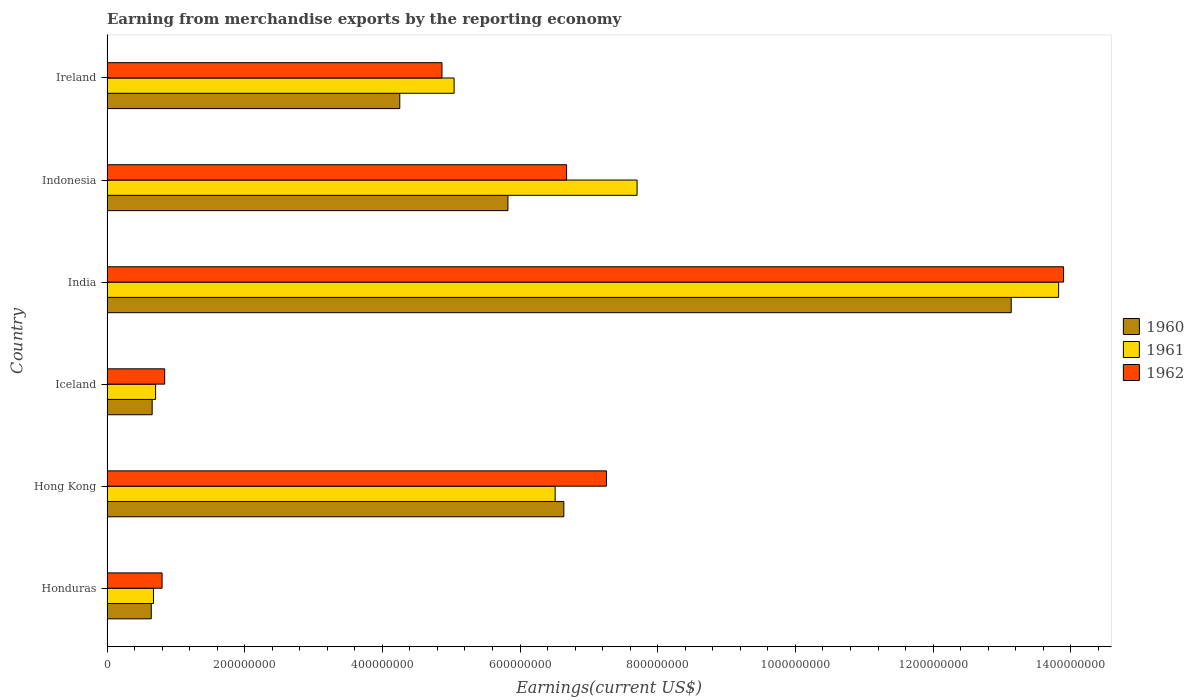How many groups of bars are there?
Your answer should be compact. 6. Are the number of bars on each tick of the Y-axis equal?
Your answer should be compact. Yes. How many bars are there on the 6th tick from the top?
Provide a short and direct response. 3. How many bars are there on the 3rd tick from the bottom?
Offer a terse response. 3. What is the amount earned from merchandise exports in 1962 in Honduras?
Offer a terse response. 8.00e+07. Across all countries, what is the maximum amount earned from merchandise exports in 1962?
Offer a terse response. 1.39e+09. Across all countries, what is the minimum amount earned from merchandise exports in 1962?
Give a very brief answer. 8.00e+07. In which country was the amount earned from merchandise exports in 1961 maximum?
Provide a short and direct response. India. In which country was the amount earned from merchandise exports in 1960 minimum?
Make the answer very short. Honduras. What is the total amount earned from merchandise exports in 1960 in the graph?
Give a very brief answer. 3.11e+09. What is the difference between the amount earned from merchandise exports in 1961 in Hong Kong and that in Indonesia?
Offer a very short reply. -1.19e+08. What is the difference between the amount earned from merchandise exports in 1960 in Honduras and the amount earned from merchandise exports in 1962 in Ireland?
Your response must be concise. -4.22e+08. What is the average amount earned from merchandise exports in 1961 per country?
Provide a succinct answer. 5.74e+08. What is the difference between the amount earned from merchandise exports in 1961 and amount earned from merchandise exports in 1960 in Honduras?
Your answer should be very brief. 3.20e+06. What is the ratio of the amount earned from merchandise exports in 1961 in Honduras to that in India?
Ensure brevity in your answer.  0.05. Is the amount earned from merchandise exports in 1962 in Iceland less than that in India?
Your answer should be compact. Yes. What is the difference between the highest and the second highest amount earned from merchandise exports in 1961?
Your answer should be very brief. 6.12e+08. What is the difference between the highest and the lowest amount earned from merchandise exports in 1961?
Offer a very short reply. 1.31e+09. What does the 1st bar from the top in Indonesia represents?
Offer a very short reply. 1962. How many bars are there?
Keep it short and to the point. 18. What is the difference between two consecutive major ticks on the X-axis?
Ensure brevity in your answer.  2.00e+08. Does the graph contain any zero values?
Ensure brevity in your answer.  No. Where does the legend appear in the graph?
Provide a short and direct response. Center right. How many legend labels are there?
Provide a short and direct response. 3. What is the title of the graph?
Provide a short and direct response. Earning from merchandise exports by the reporting economy. Does "1981" appear as one of the legend labels in the graph?
Offer a very short reply. No. What is the label or title of the X-axis?
Keep it short and to the point. Earnings(current US$). What is the label or title of the Y-axis?
Offer a very short reply. Country. What is the Earnings(current US$) of 1960 in Honduras?
Your answer should be very brief. 6.43e+07. What is the Earnings(current US$) in 1961 in Honduras?
Ensure brevity in your answer.  6.75e+07. What is the Earnings(current US$) in 1962 in Honduras?
Give a very brief answer. 8.00e+07. What is the Earnings(current US$) of 1960 in Hong Kong?
Offer a terse response. 6.64e+08. What is the Earnings(current US$) of 1961 in Hong Kong?
Give a very brief answer. 6.51e+08. What is the Earnings(current US$) of 1962 in Hong Kong?
Provide a short and direct response. 7.26e+08. What is the Earnings(current US$) in 1960 in Iceland?
Provide a short and direct response. 6.56e+07. What is the Earnings(current US$) in 1961 in Iceland?
Give a very brief answer. 7.06e+07. What is the Earnings(current US$) of 1962 in Iceland?
Offer a terse response. 8.38e+07. What is the Earnings(current US$) of 1960 in India?
Your answer should be compact. 1.31e+09. What is the Earnings(current US$) in 1961 in India?
Give a very brief answer. 1.38e+09. What is the Earnings(current US$) of 1962 in India?
Provide a short and direct response. 1.39e+09. What is the Earnings(current US$) in 1960 in Indonesia?
Give a very brief answer. 5.82e+08. What is the Earnings(current US$) of 1961 in Indonesia?
Offer a terse response. 7.70e+08. What is the Earnings(current US$) of 1962 in Indonesia?
Keep it short and to the point. 6.68e+08. What is the Earnings(current US$) of 1960 in Ireland?
Offer a terse response. 4.25e+08. What is the Earnings(current US$) in 1961 in Ireland?
Keep it short and to the point. 5.04e+08. What is the Earnings(current US$) in 1962 in Ireland?
Your answer should be very brief. 4.87e+08. Across all countries, what is the maximum Earnings(current US$) in 1960?
Your answer should be compact. 1.31e+09. Across all countries, what is the maximum Earnings(current US$) of 1961?
Make the answer very short. 1.38e+09. Across all countries, what is the maximum Earnings(current US$) of 1962?
Keep it short and to the point. 1.39e+09. Across all countries, what is the minimum Earnings(current US$) of 1960?
Ensure brevity in your answer.  6.43e+07. Across all countries, what is the minimum Earnings(current US$) in 1961?
Your answer should be very brief. 6.75e+07. Across all countries, what is the minimum Earnings(current US$) in 1962?
Your response must be concise. 8.00e+07. What is the total Earnings(current US$) of 1960 in the graph?
Keep it short and to the point. 3.11e+09. What is the total Earnings(current US$) in 1961 in the graph?
Make the answer very short. 3.45e+09. What is the total Earnings(current US$) of 1962 in the graph?
Keep it short and to the point. 3.43e+09. What is the difference between the Earnings(current US$) in 1960 in Honduras and that in Hong Kong?
Keep it short and to the point. -5.99e+08. What is the difference between the Earnings(current US$) in 1961 in Honduras and that in Hong Kong?
Give a very brief answer. -5.84e+08. What is the difference between the Earnings(current US$) in 1962 in Honduras and that in Hong Kong?
Your answer should be very brief. -6.46e+08. What is the difference between the Earnings(current US$) in 1960 in Honduras and that in Iceland?
Keep it short and to the point. -1.30e+06. What is the difference between the Earnings(current US$) in 1961 in Honduras and that in Iceland?
Provide a short and direct response. -3.10e+06. What is the difference between the Earnings(current US$) in 1962 in Honduras and that in Iceland?
Make the answer very short. -3.80e+06. What is the difference between the Earnings(current US$) of 1960 in Honduras and that in India?
Offer a very short reply. -1.25e+09. What is the difference between the Earnings(current US$) of 1961 in Honduras and that in India?
Make the answer very short. -1.31e+09. What is the difference between the Earnings(current US$) of 1962 in Honduras and that in India?
Offer a very short reply. -1.31e+09. What is the difference between the Earnings(current US$) in 1960 in Honduras and that in Indonesia?
Keep it short and to the point. -5.18e+08. What is the difference between the Earnings(current US$) of 1961 in Honduras and that in Indonesia?
Your response must be concise. -7.02e+08. What is the difference between the Earnings(current US$) of 1962 in Honduras and that in Indonesia?
Your response must be concise. -5.88e+08. What is the difference between the Earnings(current US$) of 1960 in Honduras and that in Ireland?
Provide a short and direct response. -3.61e+08. What is the difference between the Earnings(current US$) of 1961 in Honduras and that in Ireland?
Make the answer very short. -4.37e+08. What is the difference between the Earnings(current US$) in 1962 in Honduras and that in Ireland?
Your response must be concise. -4.07e+08. What is the difference between the Earnings(current US$) in 1960 in Hong Kong and that in Iceland?
Offer a very short reply. 5.98e+08. What is the difference between the Earnings(current US$) in 1961 in Hong Kong and that in Iceland?
Offer a very short reply. 5.80e+08. What is the difference between the Earnings(current US$) of 1962 in Hong Kong and that in Iceland?
Offer a terse response. 6.42e+08. What is the difference between the Earnings(current US$) in 1960 in Hong Kong and that in India?
Ensure brevity in your answer.  -6.50e+08. What is the difference between the Earnings(current US$) of 1961 in Hong Kong and that in India?
Keep it short and to the point. -7.31e+08. What is the difference between the Earnings(current US$) of 1962 in Hong Kong and that in India?
Ensure brevity in your answer.  -6.64e+08. What is the difference between the Earnings(current US$) of 1960 in Hong Kong and that in Indonesia?
Give a very brief answer. 8.12e+07. What is the difference between the Earnings(current US$) in 1961 in Hong Kong and that in Indonesia?
Offer a very short reply. -1.19e+08. What is the difference between the Earnings(current US$) in 1962 in Hong Kong and that in Indonesia?
Your answer should be compact. 5.79e+07. What is the difference between the Earnings(current US$) of 1960 in Hong Kong and that in Ireland?
Your answer should be very brief. 2.38e+08. What is the difference between the Earnings(current US$) in 1961 in Hong Kong and that in Ireland?
Your answer should be compact. 1.47e+08. What is the difference between the Earnings(current US$) in 1962 in Hong Kong and that in Ireland?
Make the answer very short. 2.39e+08. What is the difference between the Earnings(current US$) in 1960 in Iceland and that in India?
Provide a short and direct response. -1.25e+09. What is the difference between the Earnings(current US$) of 1961 in Iceland and that in India?
Your answer should be compact. -1.31e+09. What is the difference between the Earnings(current US$) in 1962 in Iceland and that in India?
Ensure brevity in your answer.  -1.31e+09. What is the difference between the Earnings(current US$) in 1960 in Iceland and that in Indonesia?
Provide a short and direct response. -5.17e+08. What is the difference between the Earnings(current US$) in 1961 in Iceland and that in Indonesia?
Offer a terse response. -6.99e+08. What is the difference between the Earnings(current US$) of 1962 in Iceland and that in Indonesia?
Keep it short and to the point. -5.84e+08. What is the difference between the Earnings(current US$) of 1960 in Iceland and that in Ireland?
Make the answer very short. -3.60e+08. What is the difference between the Earnings(current US$) in 1961 in Iceland and that in Ireland?
Make the answer very short. -4.34e+08. What is the difference between the Earnings(current US$) of 1962 in Iceland and that in Ireland?
Offer a very short reply. -4.03e+08. What is the difference between the Earnings(current US$) of 1960 in India and that in Indonesia?
Provide a succinct answer. 7.31e+08. What is the difference between the Earnings(current US$) of 1961 in India and that in Indonesia?
Your response must be concise. 6.12e+08. What is the difference between the Earnings(current US$) of 1962 in India and that in Indonesia?
Provide a short and direct response. 7.22e+08. What is the difference between the Earnings(current US$) in 1960 in India and that in Ireland?
Your answer should be compact. 8.88e+08. What is the difference between the Earnings(current US$) in 1961 in India and that in Ireland?
Offer a very short reply. 8.78e+08. What is the difference between the Earnings(current US$) of 1962 in India and that in Ireland?
Offer a very short reply. 9.03e+08. What is the difference between the Earnings(current US$) in 1960 in Indonesia and that in Ireland?
Keep it short and to the point. 1.57e+08. What is the difference between the Earnings(current US$) of 1961 in Indonesia and that in Ireland?
Provide a succinct answer. 2.66e+08. What is the difference between the Earnings(current US$) of 1962 in Indonesia and that in Ireland?
Keep it short and to the point. 1.81e+08. What is the difference between the Earnings(current US$) in 1960 in Honduras and the Earnings(current US$) in 1961 in Hong Kong?
Provide a succinct answer. -5.87e+08. What is the difference between the Earnings(current US$) of 1960 in Honduras and the Earnings(current US$) of 1962 in Hong Kong?
Your answer should be compact. -6.61e+08. What is the difference between the Earnings(current US$) of 1961 in Honduras and the Earnings(current US$) of 1962 in Hong Kong?
Offer a very short reply. -6.58e+08. What is the difference between the Earnings(current US$) in 1960 in Honduras and the Earnings(current US$) in 1961 in Iceland?
Give a very brief answer. -6.30e+06. What is the difference between the Earnings(current US$) in 1960 in Honduras and the Earnings(current US$) in 1962 in Iceland?
Make the answer very short. -1.95e+07. What is the difference between the Earnings(current US$) of 1961 in Honduras and the Earnings(current US$) of 1962 in Iceland?
Offer a terse response. -1.63e+07. What is the difference between the Earnings(current US$) in 1960 in Honduras and the Earnings(current US$) in 1961 in India?
Give a very brief answer. -1.32e+09. What is the difference between the Earnings(current US$) of 1960 in Honduras and the Earnings(current US$) of 1962 in India?
Ensure brevity in your answer.  -1.33e+09. What is the difference between the Earnings(current US$) in 1961 in Honduras and the Earnings(current US$) in 1962 in India?
Provide a succinct answer. -1.32e+09. What is the difference between the Earnings(current US$) of 1960 in Honduras and the Earnings(current US$) of 1961 in Indonesia?
Provide a short and direct response. -7.06e+08. What is the difference between the Earnings(current US$) of 1960 in Honduras and the Earnings(current US$) of 1962 in Indonesia?
Your answer should be very brief. -6.03e+08. What is the difference between the Earnings(current US$) of 1961 in Honduras and the Earnings(current US$) of 1962 in Indonesia?
Give a very brief answer. -6.00e+08. What is the difference between the Earnings(current US$) of 1960 in Honduras and the Earnings(current US$) of 1961 in Ireland?
Your response must be concise. -4.40e+08. What is the difference between the Earnings(current US$) in 1960 in Honduras and the Earnings(current US$) in 1962 in Ireland?
Your answer should be very brief. -4.22e+08. What is the difference between the Earnings(current US$) in 1961 in Honduras and the Earnings(current US$) in 1962 in Ireland?
Make the answer very short. -4.19e+08. What is the difference between the Earnings(current US$) in 1960 in Hong Kong and the Earnings(current US$) in 1961 in Iceland?
Keep it short and to the point. 5.93e+08. What is the difference between the Earnings(current US$) in 1960 in Hong Kong and the Earnings(current US$) in 1962 in Iceland?
Your response must be concise. 5.80e+08. What is the difference between the Earnings(current US$) in 1961 in Hong Kong and the Earnings(current US$) in 1962 in Iceland?
Give a very brief answer. 5.67e+08. What is the difference between the Earnings(current US$) of 1960 in Hong Kong and the Earnings(current US$) of 1961 in India?
Ensure brevity in your answer.  -7.19e+08. What is the difference between the Earnings(current US$) in 1960 in Hong Kong and the Earnings(current US$) in 1962 in India?
Your answer should be very brief. -7.26e+08. What is the difference between the Earnings(current US$) of 1961 in Hong Kong and the Earnings(current US$) of 1962 in India?
Make the answer very short. -7.38e+08. What is the difference between the Earnings(current US$) of 1960 in Hong Kong and the Earnings(current US$) of 1961 in Indonesia?
Provide a succinct answer. -1.06e+08. What is the difference between the Earnings(current US$) in 1961 in Hong Kong and the Earnings(current US$) in 1962 in Indonesia?
Give a very brief answer. -1.66e+07. What is the difference between the Earnings(current US$) of 1960 in Hong Kong and the Earnings(current US$) of 1961 in Ireland?
Ensure brevity in your answer.  1.59e+08. What is the difference between the Earnings(current US$) in 1960 in Hong Kong and the Earnings(current US$) in 1962 in Ireland?
Your response must be concise. 1.77e+08. What is the difference between the Earnings(current US$) of 1961 in Hong Kong and the Earnings(current US$) of 1962 in Ireland?
Your answer should be compact. 1.64e+08. What is the difference between the Earnings(current US$) of 1960 in Iceland and the Earnings(current US$) of 1961 in India?
Keep it short and to the point. -1.32e+09. What is the difference between the Earnings(current US$) in 1960 in Iceland and the Earnings(current US$) in 1962 in India?
Offer a very short reply. -1.32e+09. What is the difference between the Earnings(current US$) in 1961 in Iceland and the Earnings(current US$) in 1962 in India?
Your response must be concise. -1.32e+09. What is the difference between the Earnings(current US$) of 1960 in Iceland and the Earnings(current US$) of 1961 in Indonesia?
Your answer should be very brief. -7.04e+08. What is the difference between the Earnings(current US$) in 1960 in Iceland and the Earnings(current US$) in 1962 in Indonesia?
Provide a short and direct response. -6.02e+08. What is the difference between the Earnings(current US$) in 1961 in Iceland and the Earnings(current US$) in 1962 in Indonesia?
Ensure brevity in your answer.  -5.97e+08. What is the difference between the Earnings(current US$) in 1960 in Iceland and the Earnings(current US$) in 1961 in Ireland?
Provide a succinct answer. -4.39e+08. What is the difference between the Earnings(current US$) of 1960 in Iceland and the Earnings(current US$) of 1962 in Ireland?
Make the answer very short. -4.21e+08. What is the difference between the Earnings(current US$) of 1961 in Iceland and the Earnings(current US$) of 1962 in Ireland?
Offer a very short reply. -4.16e+08. What is the difference between the Earnings(current US$) in 1960 in India and the Earnings(current US$) in 1961 in Indonesia?
Offer a terse response. 5.44e+08. What is the difference between the Earnings(current US$) of 1960 in India and the Earnings(current US$) of 1962 in Indonesia?
Your response must be concise. 6.46e+08. What is the difference between the Earnings(current US$) of 1961 in India and the Earnings(current US$) of 1962 in Indonesia?
Your answer should be compact. 7.15e+08. What is the difference between the Earnings(current US$) of 1960 in India and the Earnings(current US$) of 1961 in Ireland?
Provide a short and direct response. 8.09e+08. What is the difference between the Earnings(current US$) in 1960 in India and the Earnings(current US$) in 1962 in Ireland?
Your answer should be very brief. 8.27e+08. What is the difference between the Earnings(current US$) in 1961 in India and the Earnings(current US$) in 1962 in Ireland?
Provide a short and direct response. 8.96e+08. What is the difference between the Earnings(current US$) in 1960 in Indonesia and the Earnings(current US$) in 1961 in Ireland?
Your response must be concise. 7.82e+07. What is the difference between the Earnings(current US$) of 1960 in Indonesia and the Earnings(current US$) of 1962 in Ireland?
Ensure brevity in your answer.  9.58e+07. What is the difference between the Earnings(current US$) in 1961 in Indonesia and the Earnings(current US$) in 1962 in Ireland?
Ensure brevity in your answer.  2.83e+08. What is the average Earnings(current US$) of 1960 per country?
Make the answer very short. 5.19e+08. What is the average Earnings(current US$) in 1961 per country?
Your answer should be compact. 5.74e+08. What is the average Earnings(current US$) in 1962 per country?
Your answer should be compact. 5.72e+08. What is the difference between the Earnings(current US$) of 1960 and Earnings(current US$) of 1961 in Honduras?
Offer a very short reply. -3.20e+06. What is the difference between the Earnings(current US$) in 1960 and Earnings(current US$) in 1962 in Honduras?
Give a very brief answer. -1.57e+07. What is the difference between the Earnings(current US$) in 1961 and Earnings(current US$) in 1962 in Honduras?
Make the answer very short. -1.25e+07. What is the difference between the Earnings(current US$) of 1960 and Earnings(current US$) of 1961 in Hong Kong?
Keep it short and to the point. 1.26e+07. What is the difference between the Earnings(current US$) of 1960 and Earnings(current US$) of 1962 in Hong Kong?
Offer a very short reply. -6.19e+07. What is the difference between the Earnings(current US$) of 1961 and Earnings(current US$) of 1962 in Hong Kong?
Make the answer very short. -7.45e+07. What is the difference between the Earnings(current US$) of 1960 and Earnings(current US$) of 1961 in Iceland?
Provide a short and direct response. -5.00e+06. What is the difference between the Earnings(current US$) in 1960 and Earnings(current US$) in 1962 in Iceland?
Offer a very short reply. -1.82e+07. What is the difference between the Earnings(current US$) in 1961 and Earnings(current US$) in 1962 in Iceland?
Your response must be concise. -1.32e+07. What is the difference between the Earnings(current US$) of 1960 and Earnings(current US$) of 1961 in India?
Offer a very short reply. -6.89e+07. What is the difference between the Earnings(current US$) in 1960 and Earnings(current US$) in 1962 in India?
Your answer should be compact. -7.60e+07. What is the difference between the Earnings(current US$) of 1961 and Earnings(current US$) of 1962 in India?
Keep it short and to the point. -7.10e+06. What is the difference between the Earnings(current US$) in 1960 and Earnings(current US$) in 1961 in Indonesia?
Ensure brevity in your answer.  -1.88e+08. What is the difference between the Earnings(current US$) of 1960 and Earnings(current US$) of 1962 in Indonesia?
Provide a short and direct response. -8.52e+07. What is the difference between the Earnings(current US$) in 1961 and Earnings(current US$) in 1962 in Indonesia?
Your answer should be compact. 1.02e+08. What is the difference between the Earnings(current US$) of 1960 and Earnings(current US$) of 1961 in Ireland?
Give a very brief answer. -7.89e+07. What is the difference between the Earnings(current US$) of 1960 and Earnings(current US$) of 1962 in Ireland?
Give a very brief answer. -6.13e+07. What is the difference between the Earnings(current US$) of 1961 and Earnings(current US$) of 1962 in Ireland?
Offer a terse response. 1.76e+07. What is the ratio of the Earnings(current US$) of 1960 in Honduras to that in Hong Kong?
Provide a short and direct response. 0.1. What is the ratio of the Earnings(current US$) in 1961 in Honduras to that in Hong Kong?
Provide a short and direct response. 0.1. What is the ratio of the Earnings(current US$) in 1962 in Honduras to that in Hong Kong?
Offer a very short reply. 0.11. What is the ratio of the Earnings(current US$) of 1960 in Honduras to that in Iceland?
Offer a very short reply. 0.98. What is the ratio of the Earnings(current US$) of 1961 in Honduras to that in Iceland?
Your answer should be very brief. 0.96. What is the ratio of the Earnings(current US$) of 1962 in Honduras to that in Iceland?
Ensure brevity in your answer.  0.95. What is the ratio of the Earnings(current US$) in 1960 in Honduras to that in India?
Ensure brevity in your answer.  0.05. What is the ratio of the Earnings(current US$) in 1961 in Honduras to that in India?
Give a very brief answer. 0.05. What is the ratio of the Earnings(current US$) in 1962 in Honduras to that in India?
Offer a very short reply. 0.06. What is the ratio of the Earnings(current US$) in 1960 in Honduras to that in Indonesia?
Provide a succinct answer. 0.11. What is the ratio of the Earnings(current US$) in 1961 in Honduras to that in Indonesia?
Make the answer very short. 0.09. What is the ratio of the Earnings(current US$) in 1962 in Honduras to that in Indonesia?
Provide a succinct answer. 0.12. What is the ratio of the Earnings(current US$) in 1960 in Honduras to that in Ireland?
Offer a very short reply. 0.15. What is the ratio of the Earnings(current US$) of 1961 in Honduras to that in Ireland?
Make the answer very short. 0.13. What is the ratio of the Earnings(current US$) of 1962 in Honduras to that in Ireland?
Your answer should be compact. 0.16. What is the ratio of the Earnings(current US$) in 1960 in Hong Kong to that in Iceland?
Ensure brevity in your answer.  10.12. What is the ratio of the Earnings(current US$) in 1961 in Hong Kong to that in Iceland?
Provide a short and direct response. 9.22. What is the ratio of the Earnings(current US$) of 1962 in Hong Kong to that in Iceland?
Provide a short and direct response. 8.66. What is the ratio of the Earnings(current US$) of 1960 in Hong Kong to that in India?
Make the answer very short. 0.51. What is the ratio of the Earnings(current US$) of 1961 in Hong Kong to that in India?
Your answer should be very brief. 0.47. What is the ratio of the Earnings(current US$) of 1962 in Hong Kong to that in India?
Ensure brevity in your answer.  0.52. What is the ratio of the Earnings(current US$) in 1960 in Hong Kong to that in Indonesia?
Your response must be concise. 1.14. What is the ratio of the Earnings(current US$) of 1961 in Hong Kong to that in Indonesia?
Ensure brevity in your answer.  0.85. What is the ratio of the Earnings(current US$) of 1962 in Hong Kong to that in Indonesia?
Keep it short and to the point. 1.09. What is the ratio of the Earnings(current US$) of 1960 in Hong Kong to that in Ireland?
Keep it short and to the point. 1.56. What is the ratio of the Earnings(current US$) in 1961 in Hong Kong to that in Ireland?
Ensure brevity in your answer.  1.29. What is the ratio of the Earnings(current US$) in 1962 in Hong Kong to that in Ireland?
Ensure brevity in your answer.  1.49. What is the ratio of the Earnings(current US$) in 1960 in Iceland to that in India?
Offer a terse response. 0.05. What is the ratio of the Earnings(current US$) in 1961 in Iceland to that in India?
Provide a short and direct response. 0.05. What is the ratio of the Earnings(current US$) of 1962 in Iceland to that in India?
Offer a very short reply. 0.06. What is the ratio of the Earnings(current US$) of 1960 in Iceland to that in Indonesia?
Provide a succinct answer. 0.11. What is the ratio of the Earnings(current US$) of 1961 in Iceland to that in Indonesia?
Keep it short and to the point. 0.09. What is the ratio of the Earnings(current US$) of 1962 in Iceland to that in Indonesia?
Offer a terse response. 0.13. What is the ratio of the Earnings(current US$) of 1960 in Iceland to that in Ireland?
Keep it short and to the point. 0.15. What is the ratio of the Earnings(current US$) of 1961 in Iceland to that in Ireland?
Make the answer very short. 0.14. What is the ratio of the Earnings(current US$) of 1962 in Iceland to that in Ireland?
Offer a terse response. 0.17. What is the ratio of the Earnings(current US$) in 1960 in India to that in Indonesia?
Keep it short and to the point. 2.26. What is the ratio of the Earnings(current US$) in 1961 in India to that in Indonesia?
Your response must be concise. 1.8. What is the ratio of the Earnings(current US$) of 1962 in India to that in Indonesia?
Give a very brief answer. 2.08. What is the ratio of the Earnings(current US$) in 1960 in India to that in Ireland?
Provide a short and direct response. 3.09. What is the ratio of the Earnings(current US$) of 1961 in India to that in Ireland?
Provide a short and direct response. 2.74. What is the ratio of the Earnings(current US$) in 1962 in India to that in Ireland?
Provide a succinct answer. 2.86. What is the ratio of the Earnings(current US$) in 1960 in Indonesia to that in Ireland?
Your response must be concise. 1.37. What is the ratio of the Earnings(current US$) in 1961 in Indonesia to that in Ireland?
Offer a very short reply. 1.53. What is the ratio of the Earnings(current US$) in 1962 in Indonesia to that in Ireland?
Keep it short and to the point. 1.37. What is the difference between the highest and the second highest Earnings(current US$) in 1960?
Provide a succinct answer. 6.50e+08. What is the difference between the highest and the second highest Earnings(current US$) of 1961?
Offer a very short reply. 6.12e+08. What is the difference between the highest and the second highest Earnings(current US$) in 1962?
Offer a terse response. 6.64e+08. What is the difference between the highest and the lowest Earnings(current US$) in 1960?
Your answer should be compact. 1.25e+09. What is the difference between the highest and the lowest Earnings(current US$) in 1961?
Ensure brevity in your answer.  1.31e+09. What is the difference between the highest and the lowest Earnings(current US$) of 1962?
Your response must be concise. 1.31e+09. 